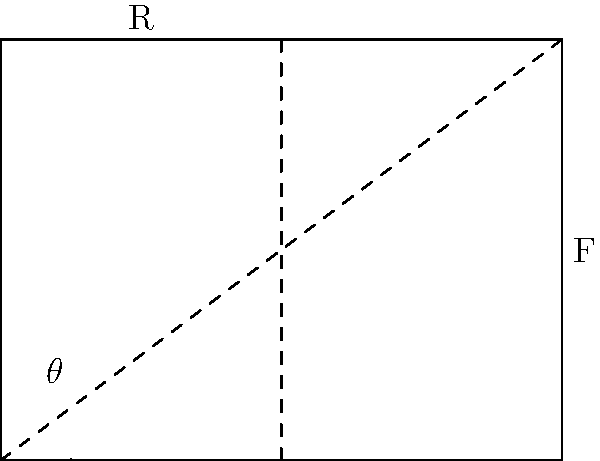In the force diagram shown, a bridge support structure is represented by the right triangle. The vertical force F is applied at point B, and the reaction force R is at point C. What is the optimal angle $\theta$ for the support beam OB to minimize the stress on the beam? To find the optimal angle $\theta$ that minimizes stress on the support beam OB, we need to follow these steps:

1) The stress on the beam is proportional to the force along the beam. This force is the component of F that acts along OB.

2) The force along OB can be expressed as $F \cos(\alpha)$, where $\alpha$ is the angle between F and OB.

3) We want to maximize $\cos(\alpha)$ to minimize the stress (as $F$ is constant).

4) In a right triangle, $\cos(\alpha)$ is maximum when $\alpha = 45°$.

5) For $\alpha$ to be 45°, the triangle OAB must be isosceles, meaning OB = AB.

6) In an isosceles right triangle, the angle between the hypotenuse and either leg is 45°.

Therefore, the optimal angle $\theta$ for the support beam OB is 45°. This configuration ensures that the force along the beam is minimized, thus reducing the stress on the structure.
Answer: 45° 